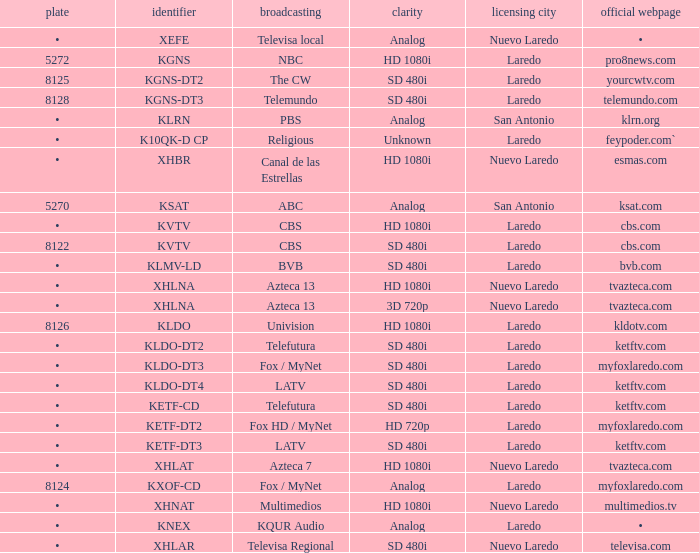Name the resolution for ketftv.com and callsign of kldo-dt2 SD 480i. 